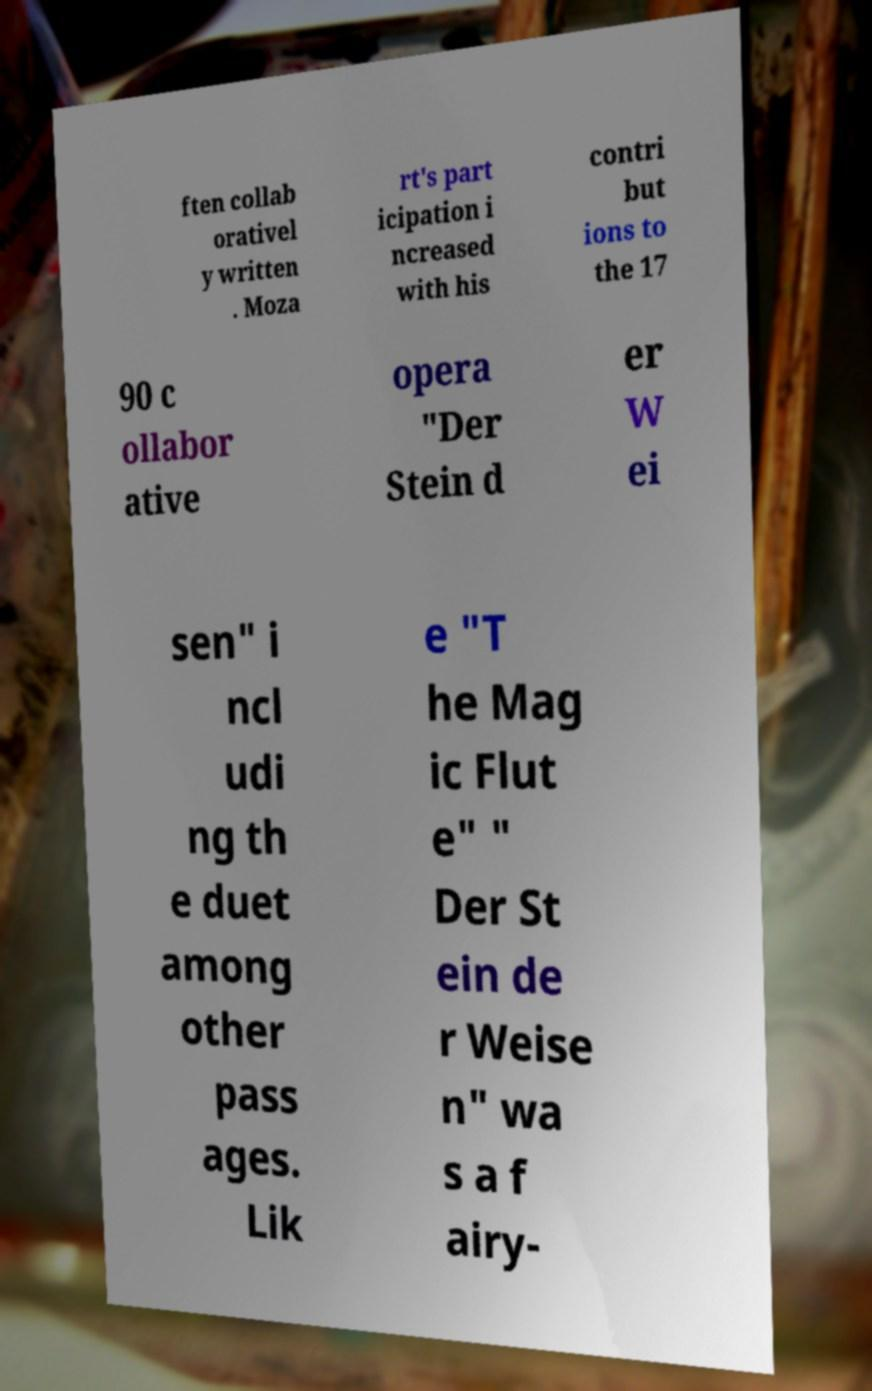For documentation purposes, I need the text within this image transcribed. Could you provide that? ften collab orativel y written . Moza rt's part icipation i ncreased with his contri but ions to the 17 90 c ollabor ative opera "Der Stein d er W ei sen" i ncl udi ng th e duet among other pass ages. Lik e "T he Mag ic Flut e" " Der St ein de r Weise n" wa s a f airy- 